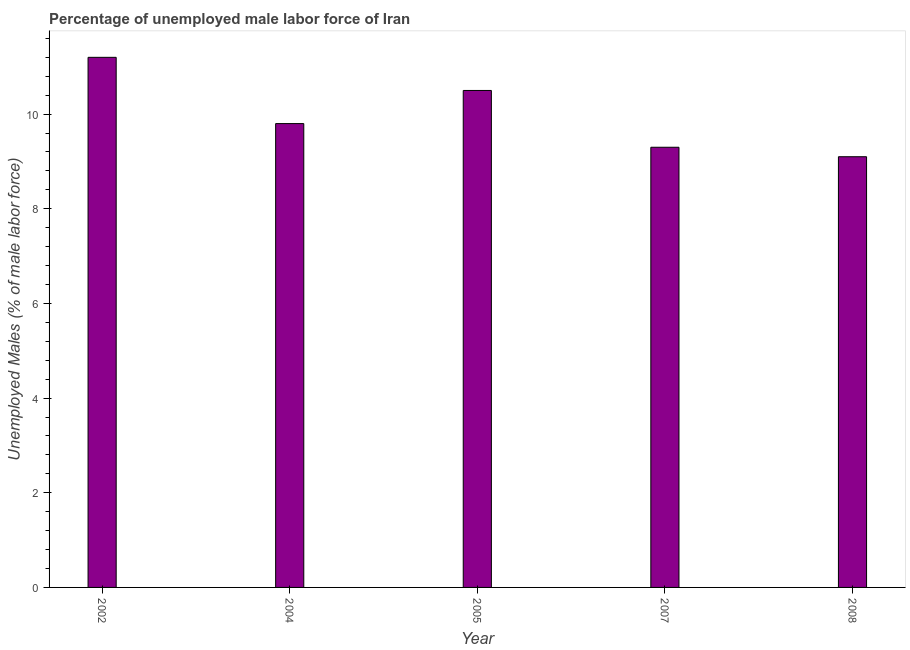What is the title of the graph?
Make the answer very short. Percentage of unemployed male labor force of Iran. What is the label or title of the Y-axis?
Make the answer very short. Unemployed Males (% of male labor force). What is the total unemployed male labour force in 2004?
Your response must be concise. 9.8. Across all years, what is the maximum total unemployed male labour force?
Ensure brevity in your answer.  11.2. Across all years, what is the minimum total unemployed male labour force?
Make the answer very short. 9.1. In which year was the total unemployed male labour force minimum?
Your answer should be very brief. 2008. What is the sum of the total unemployed male labour force?
Your answer should be compact. 49.9. What is the average total unemployed male labour force per year?
Give a very brief answer. 9.98. What is the median total unemployed male labour force?
Offer a very short reply. 9.8. What is the ratio of the total unemployed male labour force in 2002 to that in 2008?
Offer a terse response. 1.23. Is the difference between the total unemployed male labour force in 2002 and 2008 greater than the difference between any two years?
Provide a succinct answer. Yes. In how many years, is the total unemployed male labour force greater than the average total unemployed male labour force taken over all years?
Your answer should be compact. 2. How many bars are there?
Your answer should be very brief. 5. Are all the bars in the graph horizontal?
Your answer should be very brief. No. What is the Unemployed Males (% of male labor force) of 2002?
Give a very brief answer. 11.2. What is the Unemployed Males (% of male labor force) of 2004?
Provide a short and direct response. 9.8. What is the Unemployed Males (% of male labor force) in 2007?
Your answer should be very brief. 9.3. What is the Unemployed Males (% of male labor force) in 2008?
Keep it short and to the point. 9.1. What is the difference between the Unemployed Males (% of male labor force) in 2002 and 2005?
Provide a short and direct response. 0.7. What is the difference between the Unemployed Males (% of male labor force) in 2002 and 2007?
Ensure brevity in your answer.  1.9. What is the difference between the Unemployed Males (% of male labor force) in 2004 and 2007?
Keep it short and to the point. 0.5. What is the difference between the Unemployed Males (% of male labor force) in 2004 and 2008?
Your answer should be compact. 0.7. What is the difference between the Unemployed Males (% of male labor force) in 2005 and 2007?
Your response must be concise. 1.2. What is the difference between the Unemployed Males (% of male labor force) in 2005 and 2008?
Provide a succinct answer. 1.4. What is the difference between the Unemployed Males (% of male labor force) in 2007 and 2008?
Provide a succinct answer. 0.2. What is the ratio of the Unemployed Males (% of male labor force) in 2002 to that in 2004?
Provide a succinct answer. 1.14. What is the ratio of the Unemployed Males (% of male labor force) in 2002 to that in 2005?
Your answer should be very brief. 1.07. What is the ratio of the Unemployed Males (% of male labor force) in 2002 to that in 2007?
Your answer should be compact. 1.2. What is the ratio of the Unemployed Males (% of male labor force) in 2002 to that in 2008?
Offer a terse response. 1.23. What is the ratio of the Unemployed Males (% of male labor force) in 2004 to that in 2005?
Give a very brief answer. 0.93. What is the ratio of the Unemployed Males (% of male labor force) in 2004 to that in 2007?
Ensure brevity in your answer.  1.05. What is the ratio of the Unemployed Males (% of male labor force) in 2004 to that in 2008?
Provide a succinct answer. 1.08. What is the ratio of the Unemployed Males (% of male labor force) in 2005 to that in 2007?
Offer a terse response. 1.13. What is the ratio of the Unemployed Males (% of male labor force) in 2005 to that in 2008?
Keep it short and to the point. 1.15. What is the ratio of the Unemployed Males (% of male labor force) in 2007 to that in 2008?
Provide a succinct answer. 1.02. 